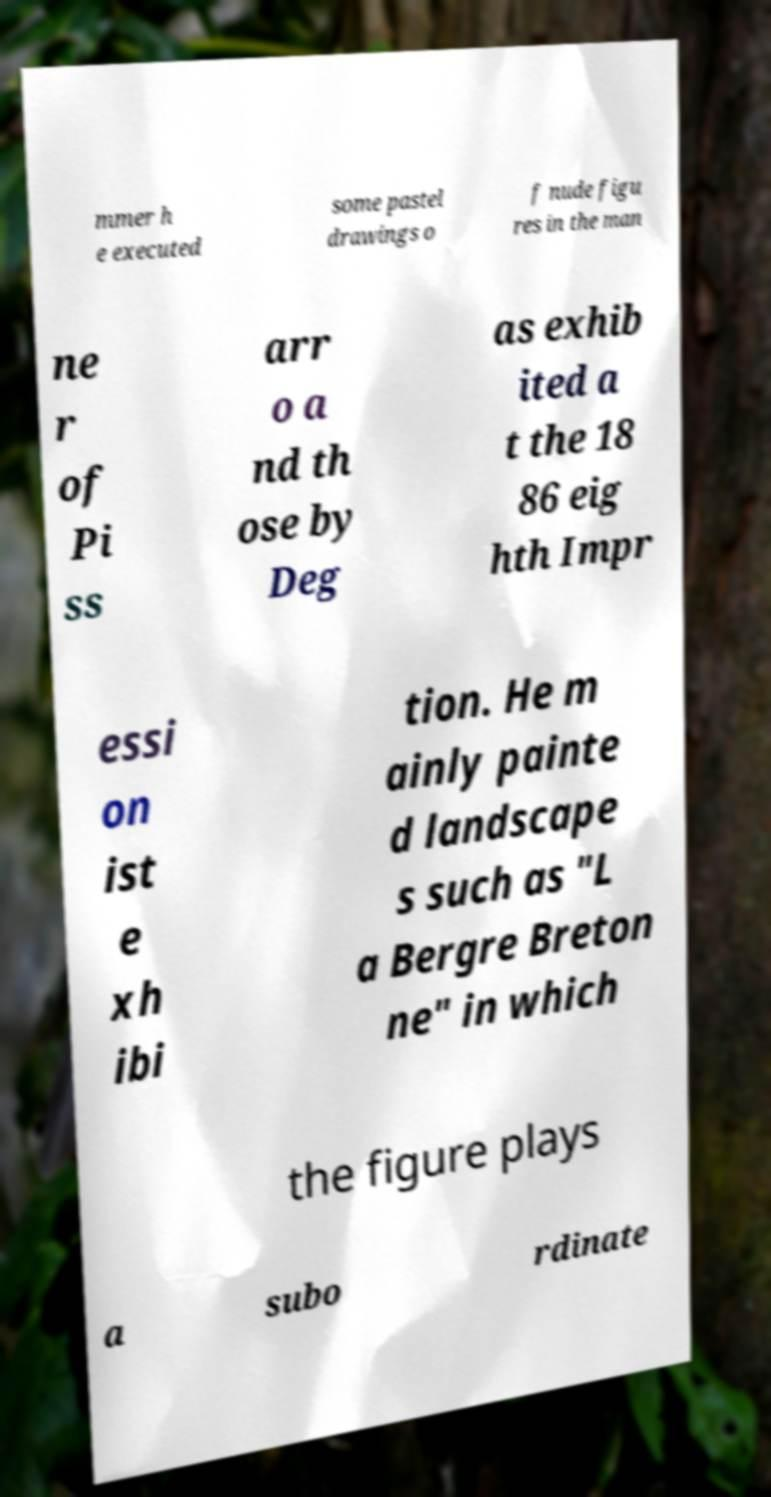Could you extract and type out the text from this image? mmer h e executed some pastel drawings o f nude figu res in the man ne r of Pi ss arr o a nd th ose by Deg as exhib ited a t the 18 86 eig hth Impr essi on ist e xh ibi tion. He m ainly painte d landscape s such as "L a Bergre Breton ne" in which the figure plays a subo rdinate 